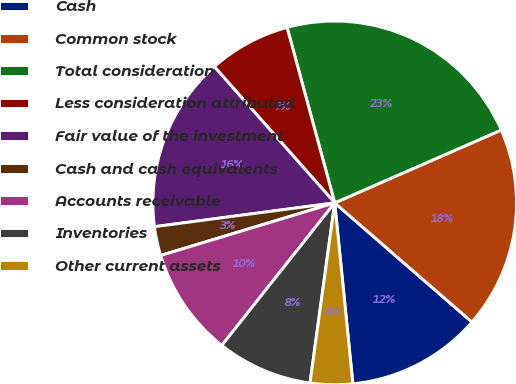Convert chart. <chart><loc_0><loc_0><loc_500><loc_500><pie_chart><fcel>Cash<fcel>Common stock<fcel>Total consideration<fcel>Less consideration attributed<fcel>Fair value of the investment<fcel>Cash and cash equivalents<fcel>Accounts receivable<fcel>Inventories<fcel>Other current assets<nl><fcel>12.03%<fcel>17.94%<fcel>22.66%<fcel>7.3%<fcel>15.57%<fcel>2.58%<fcel>9.67%<fcel>8.49%<fcel>3.76%<nl></chart> 